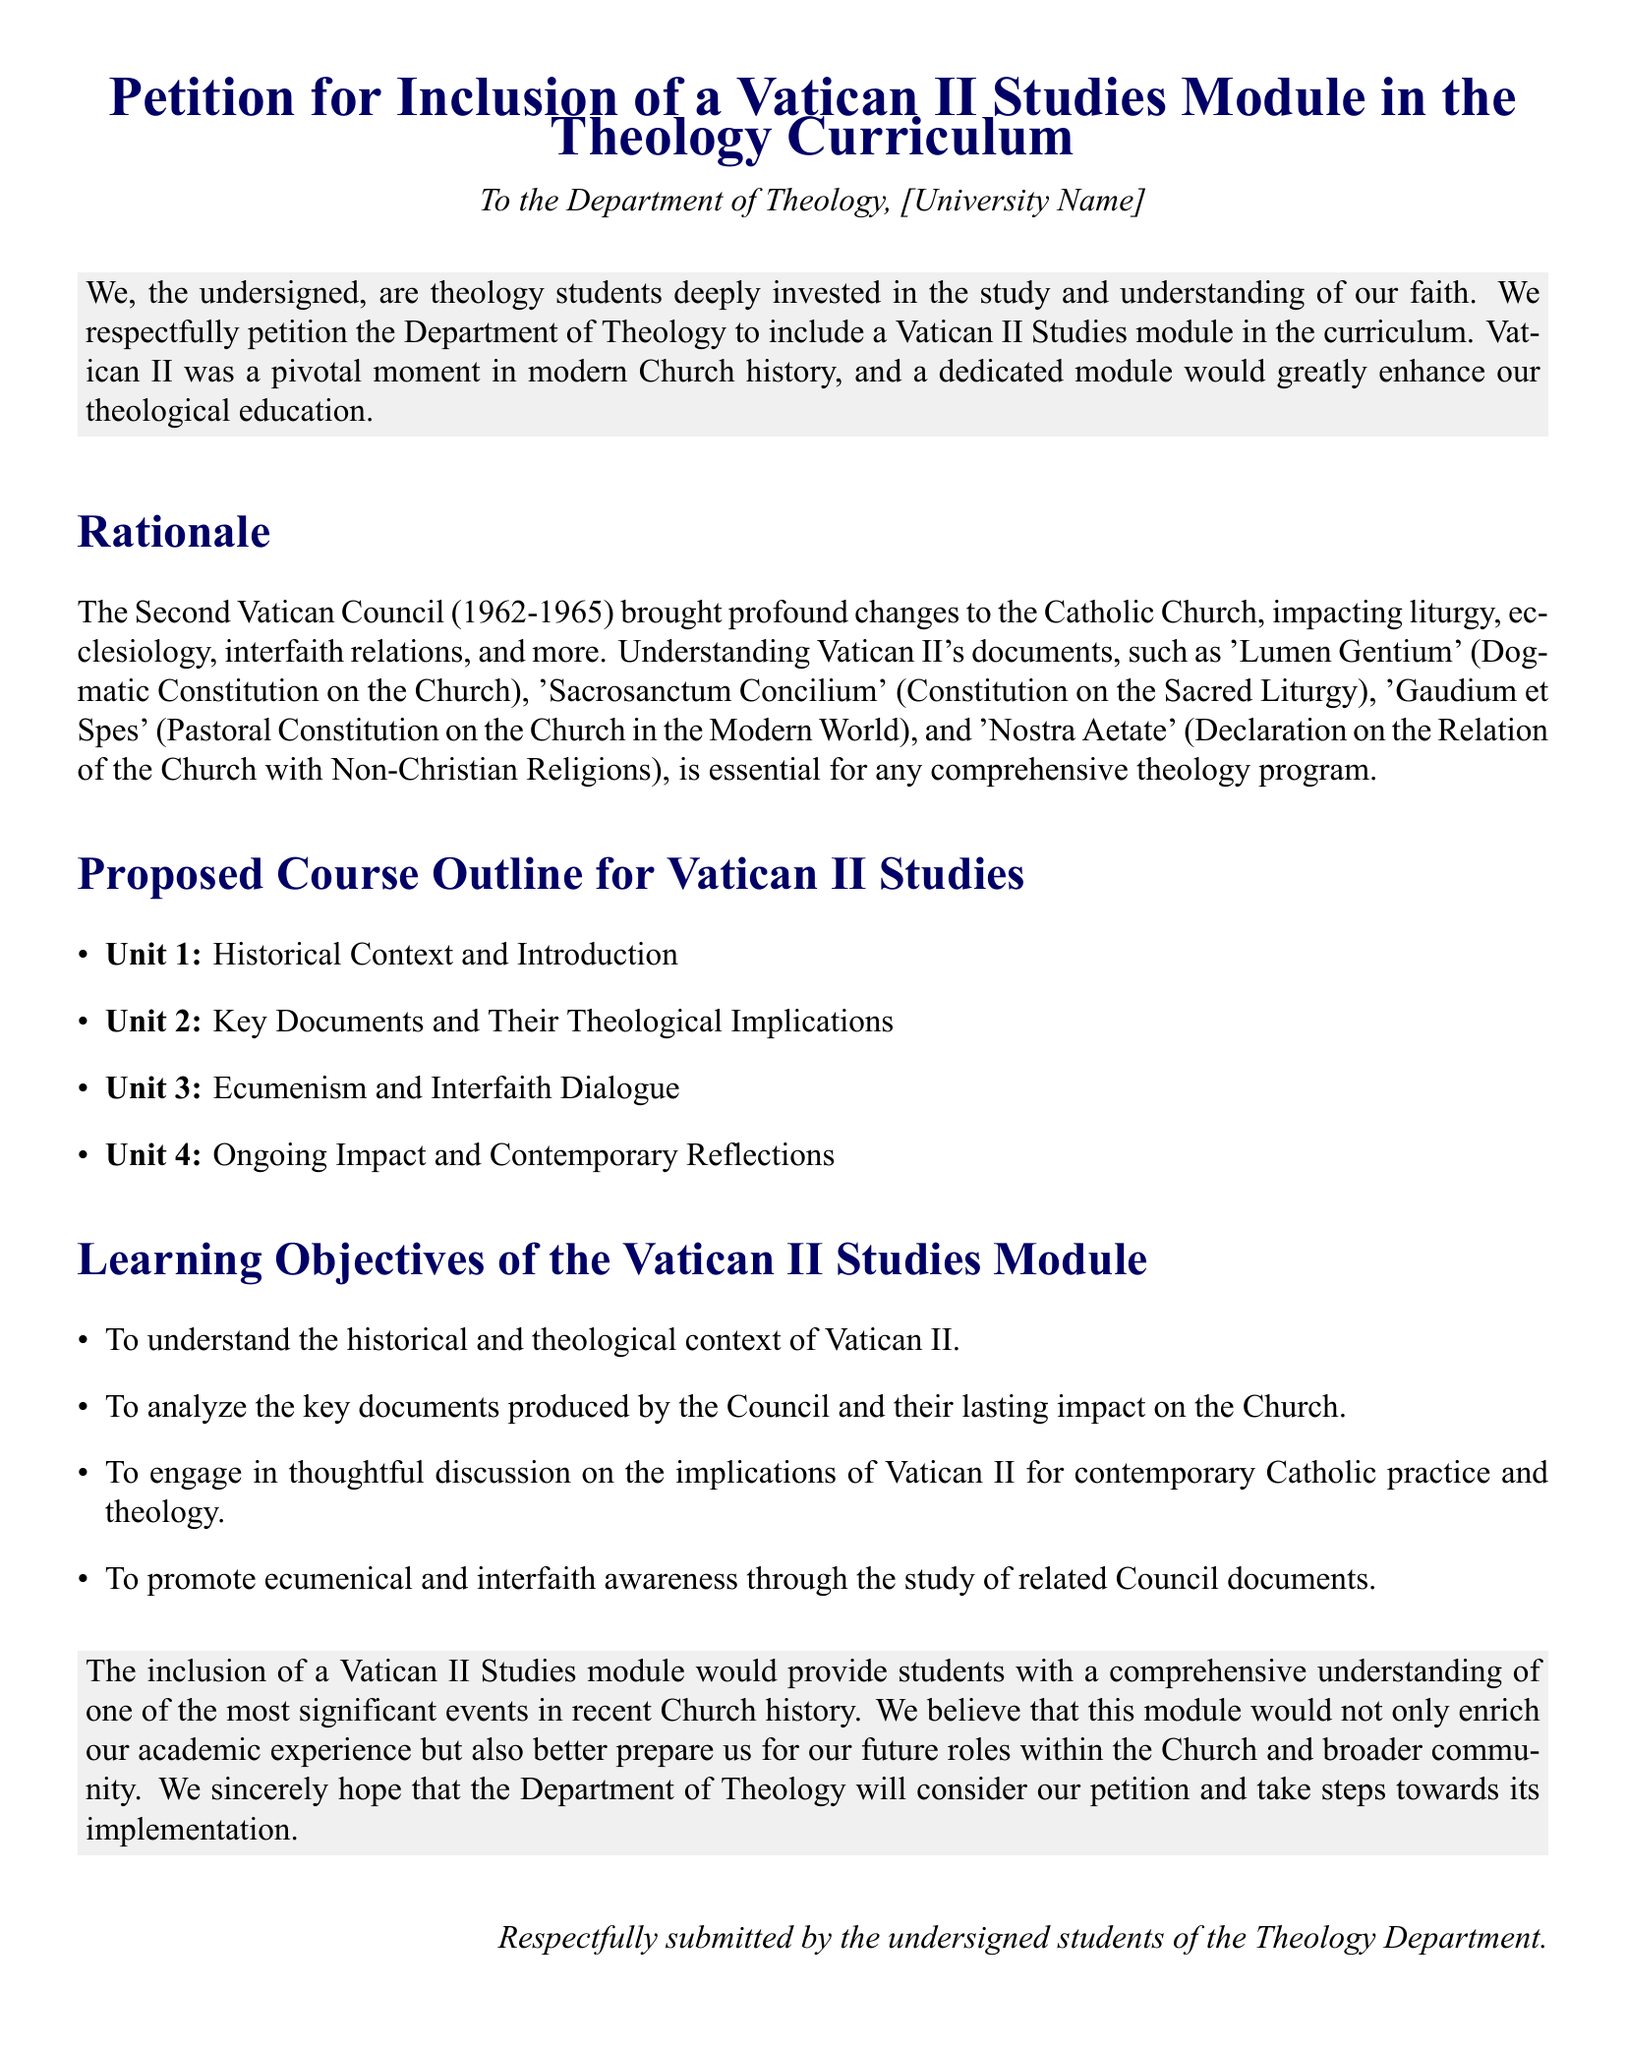What is the title of the document? The title is clearly stated at the beginning of the document as the official title of the petition.
Answer: Petition for Inclusion of a Vatican II Studies Module in the Theology Curriculum Who is the petition addressed to? The petition explicitly mentions the recipient of the petition in the introductory section.
Answer: Department of Theology, [University Name] How many units are proposed in the course outline? The course outline lists four distinct units under the proposed course.
Answer: 4 What is the first unit of the proposed course outline? The first unit is specified in the course outline section of the document.
Answer: Historical Context and Introduction What is the second learning objective of the module? The learning objectives are enumerated with specific purposes outlined in the document.
Answer: To analyze the key documents produced by the Council and their lasting impact on the Church Explain the significance of Vatican II according to the rationale. The rationale outlines that Vatican II brought profound changes and is essential for understanding key aspects of the Church.
Answer: Pivotal moment in modern Church history What kind of awareness does the module aim to promote? The specific type of awareness to be promoted is explicitly stated in the learning objectives.
Answer: Ecumenical and interfaith awareness What year did Vatican II take place? The document states the period during which Vatican II occurred.
Answer: 1962-1965 What is the final statement in the petition section? The closing statement summarizes the hope and request made by the students in the document.
Answer: We sincerely hope that the Department of Theology will consider our petition and take steps towards its implementation 